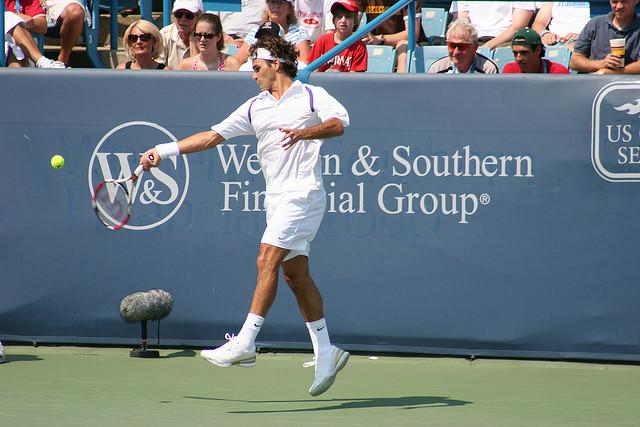What is traveling towards the man? Please explain your reasoning. tennis ball. The man is going to hit the ball. 